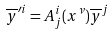Convert formula to latex. <formula><loc_0><loc_0><loc_500><loc_500>\overline { y } ^ { \prime i } = A _ { j } ^ { i } ( x ^ { \nu } ) \overline { y } ^ { j }</formula> 